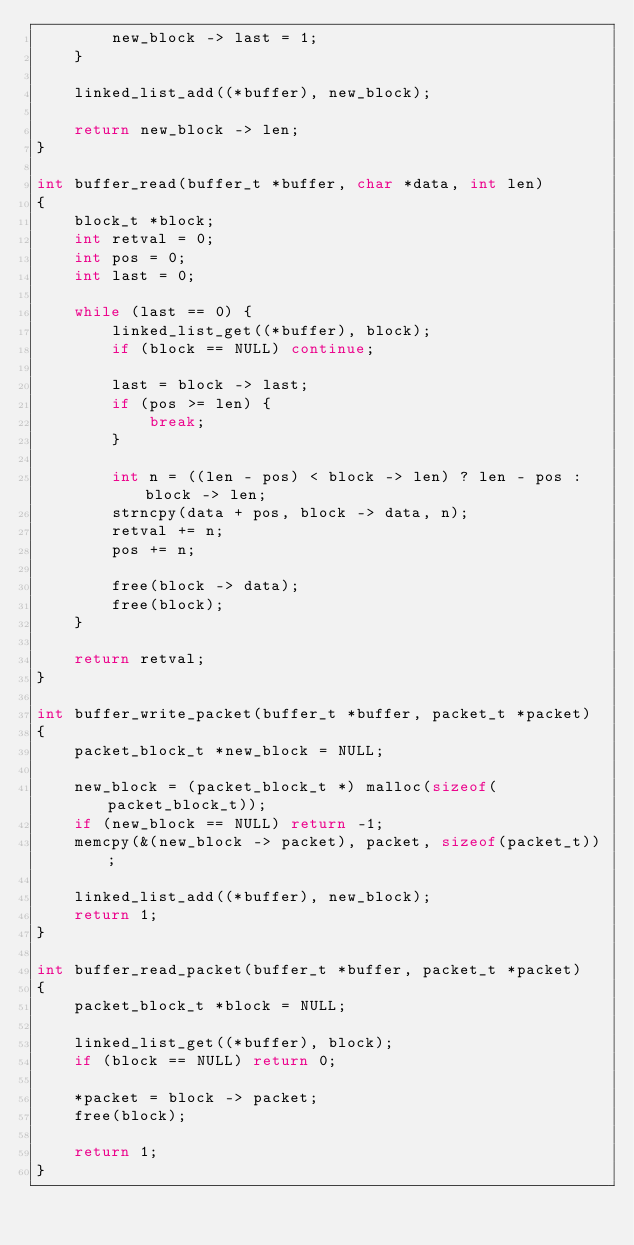<code> <loc_0><loc_0><loc_500><loc_500><_C_>        new_block -> last = 1;
    }

    linked_list_add((*buffer), new_block);

    return new_block -> len;
}

int buffer_read(buffer_t *buffer, char *data, int len)
{
    block_t *block;
    int retval = 0;
    int pos = 0;
    int last = 0;

    while (last == 0) {
        linked_list_get((*buffer), block);
        if (block == NULL) continue;

        last = block -> last;
        if (pos >= len) {
            break;
        }

        int n = ((len - pos) < block -> len) ? len - pos : block -> len;
        strncpy(data + pos, block -> data, n);
        retval += n;
        pos += n;

        free(block -> data);
        free(block);
    }

    return retval;
}

int buffer_write_packet(buffer_t *buffer, packet_t *packet)
{
    packet_block_t *new_block = NULL;

    new_block = (packet_block_t *) malloc(sizeof(packet_block_t));
    if (new_block == NULL) return -1;
    memcpy(&(new_block -> packet), packet, sizeof(packet_t));

    linked_list_add((*buffer), new_block);
    return 1;
}

int buffer_read_packet(buffer_t *buffer, packet_t *packet)
{
    packet_block_t *block = NULL;

    linked_list_get((*buffer), block);
    if (block == NULL) return 0;

    *packet = block -> packet;
    free(block);

    return 1;
}
</code> 